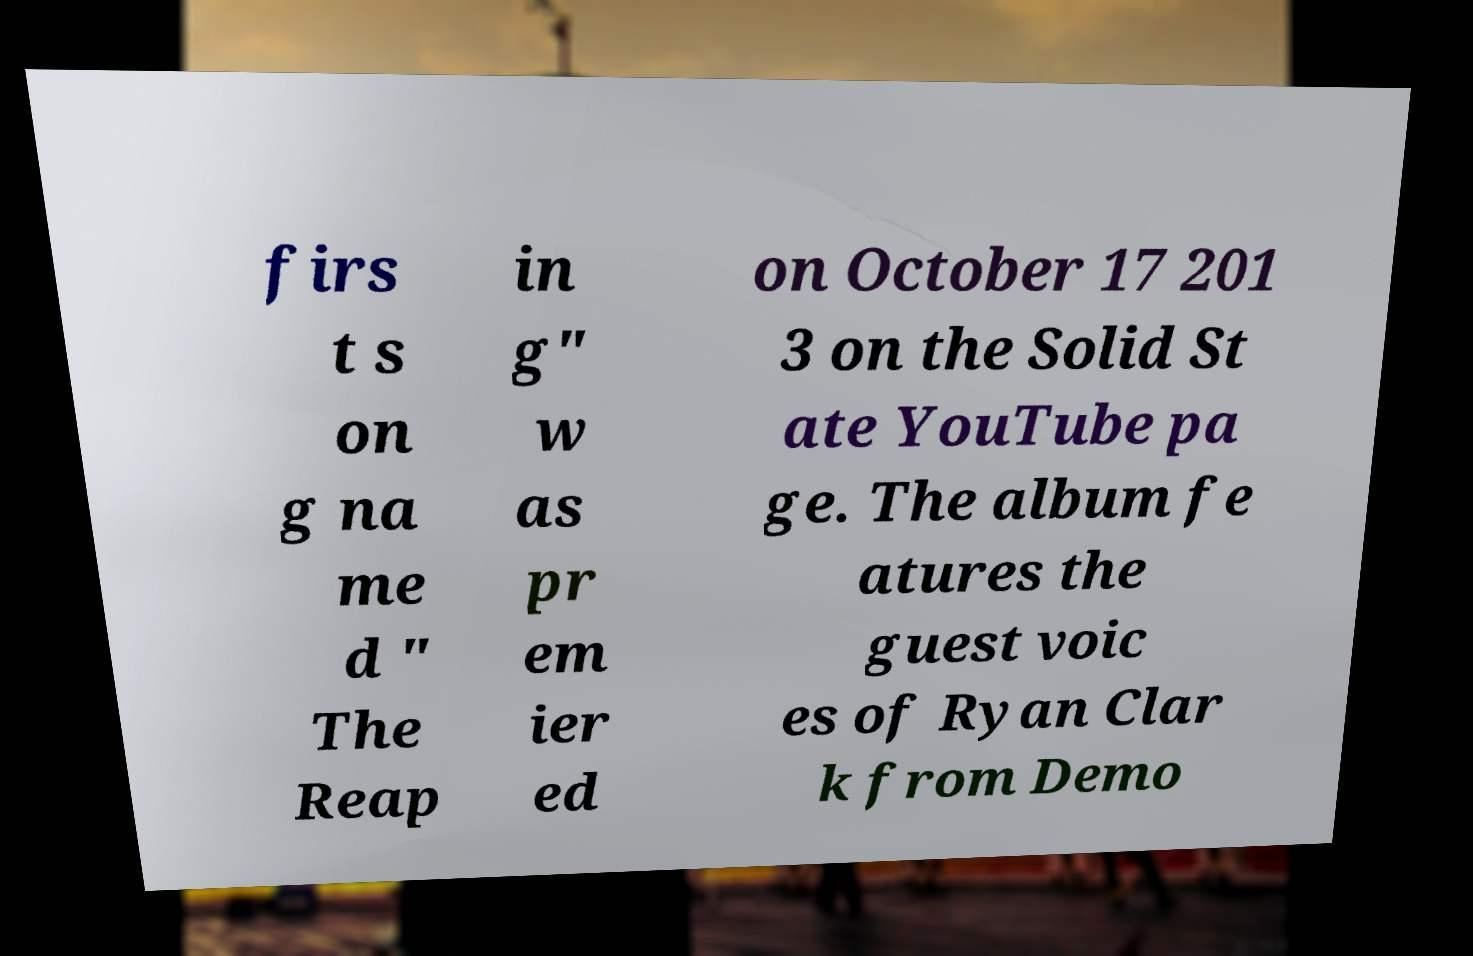Can you read and provide the text displayed in the image?This photo seems to have some interesting text. Can you extract and type it out for me? firs t s on g na me d " The Reap in g" w as pr em ier ed on October 17 201 3 on the Solid St ate YouTube pa ge. The album fe atures the guest voic es of Ryan Clar k from Demo 